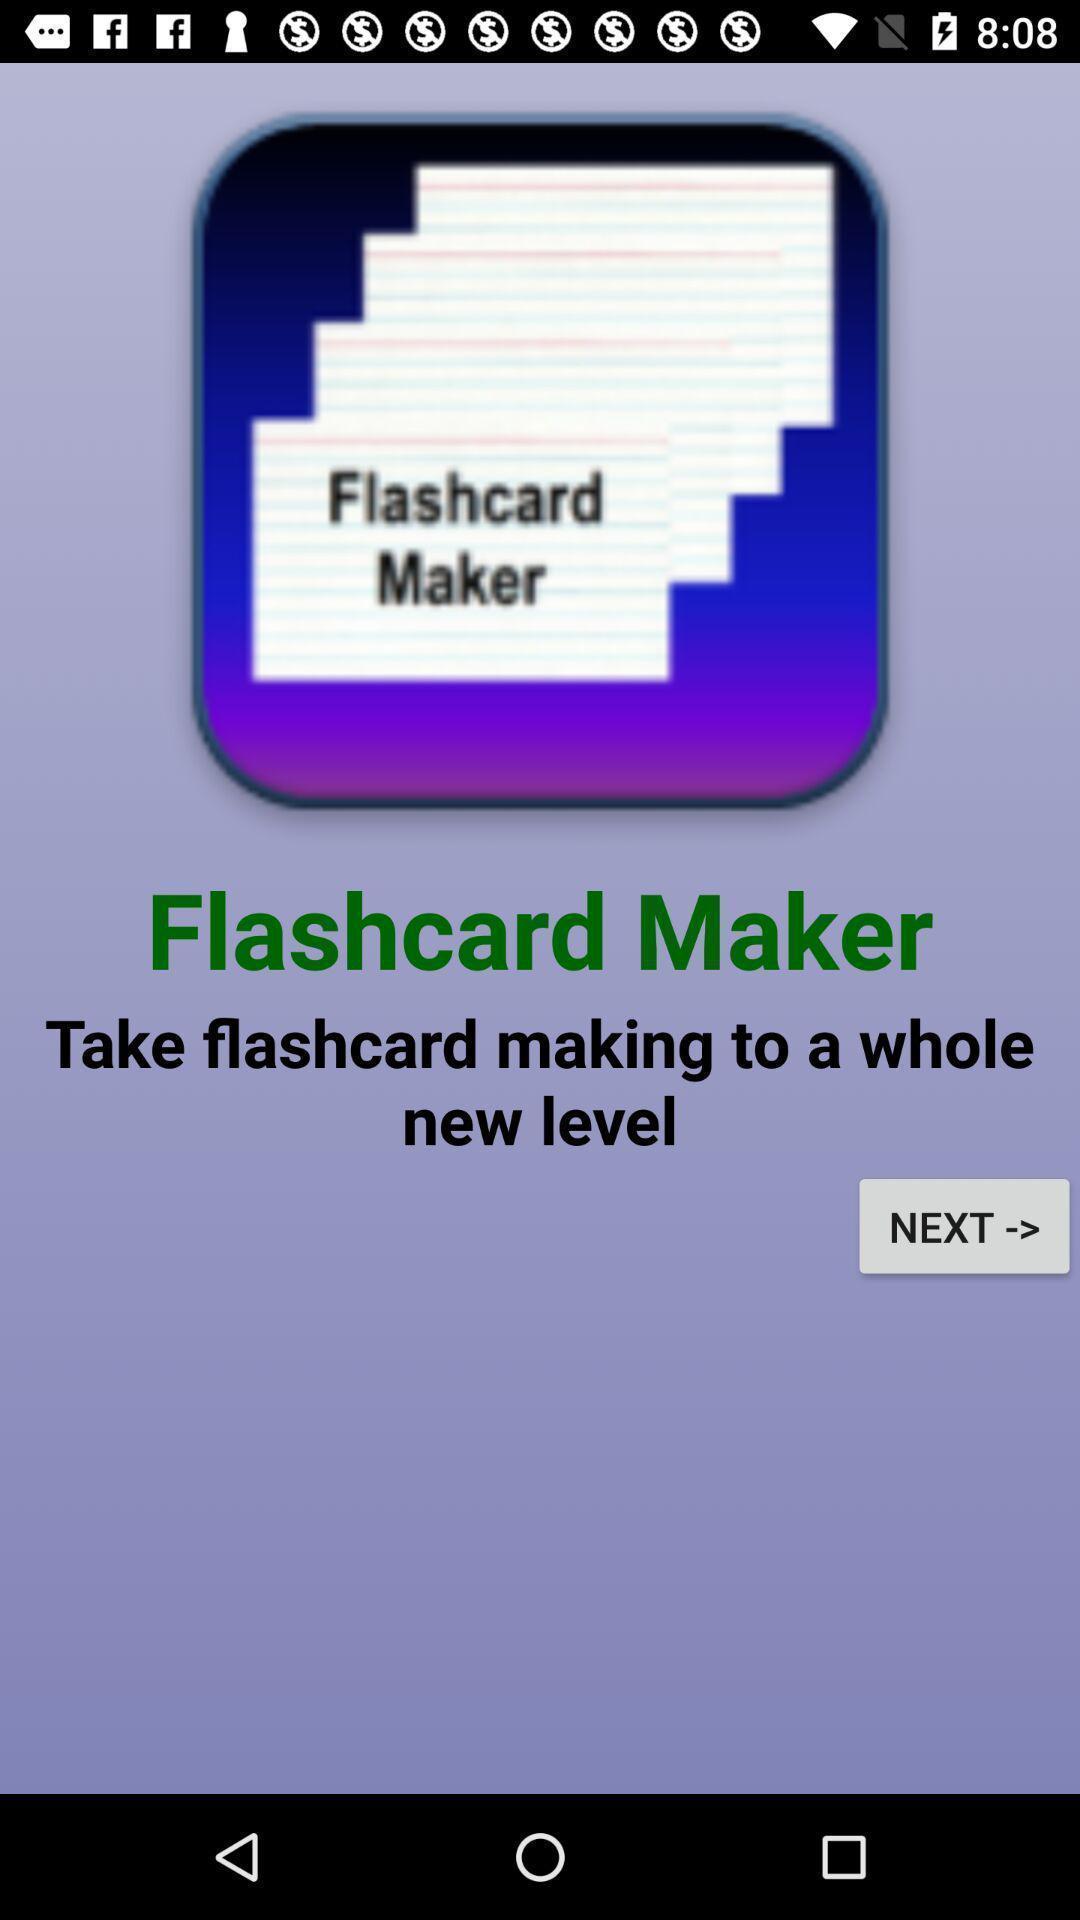Provide a textual representation of this image. Welcome page. 